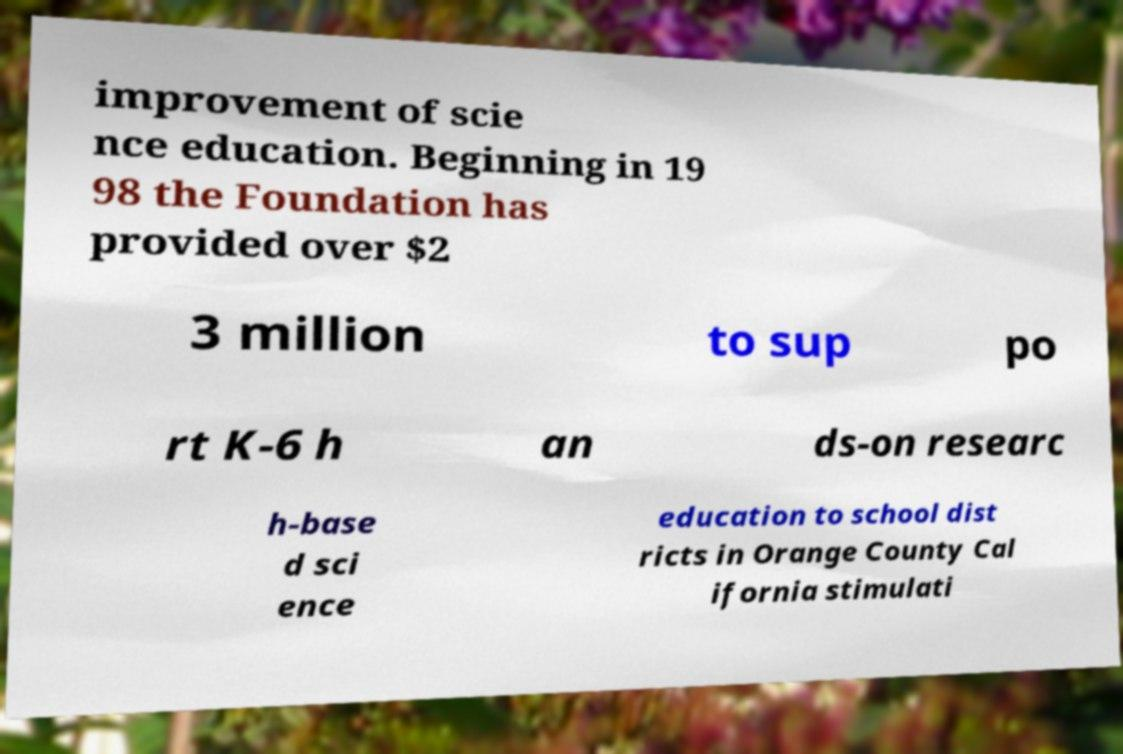I need the written content from this picture converted into text. Can you do that? improvement of scie nce education. Beginning in 19 98 the Foundation has provided over $2 3 million to sup po rt K-6 h an ds-on researc h-base d sci ence education to school dist ricts in Orange County Cal ifornia stimulati 